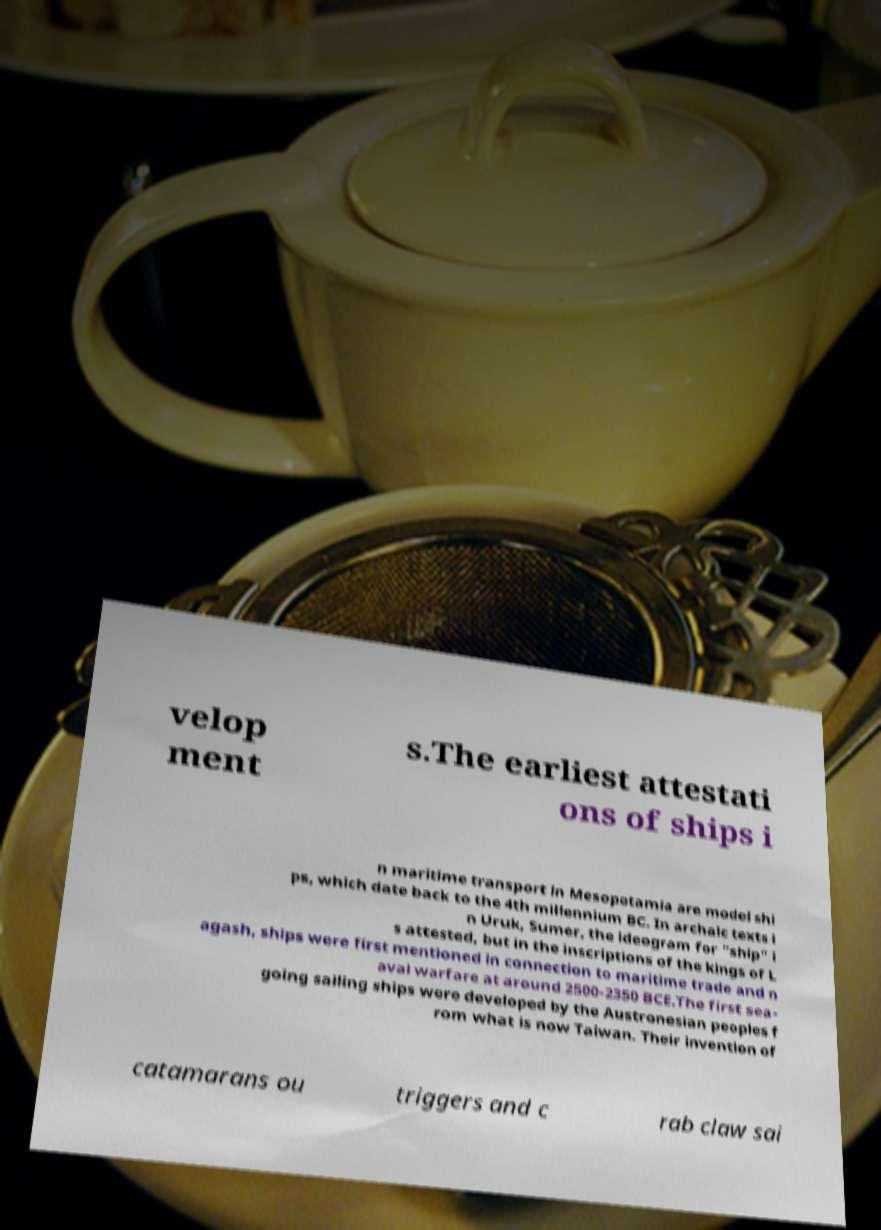There's text embedded in this image that I need extracted. Can you transcribe it verbatim? velop ment s.The earliest attestati ons of ships i n maritime transport in Mesopotamia are model shi ps, which date back to the 4th millennium BC. In archaic texts i n Uruk, Sumer, the ideogram for "ship" i s attested, but in the inscriptions of the kings of L agash, ships were first mentioned in connection to maritime trade and n aval warfare at around 2500-2350 BCE.The first sea- going sailing ships were developed by the Austronesian peoples f rom what is now Taiwan. Their invention of catamarans ou triggers and c rab claw sai 